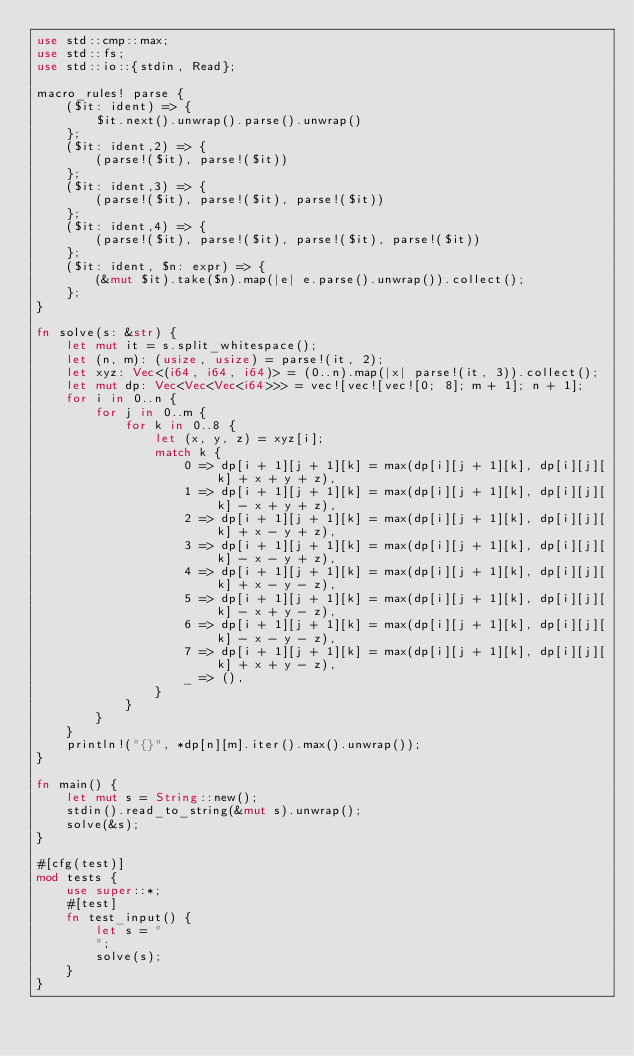Convert code to text. <code><loc_0><loc_0><loc_500><loc_500><_Rust_>use std::cmp::max;
use std::fs;
use std::io::{stdin, Read};

macro_rules! parse {
    ($it: ident) => {
        $it.next().unwrap().parse().unwrap()
    };
    ($it: ident,2) => {
        (parse!($it), parse!($it))
    };
    ($it: ident,3) => {
        (parse!($it), parse!($it), parse!($it))
    };
    ($it: ident,4) => {
        (parse!($it), parse!($it), parse!($it), parse!($it))
    };
    ($it: ident, $n: expr) => {
        (&mut $it).take($n).map(|e| e.parse().unwrap()).collect();
    };
}

fn solve(s: &str) {
    let mut it = s.split_whitespace();
    let (n, m): (usize, usize) = parse!(it, 2);
    let xyz: Vec<(i64, i64, i64)> = (0..n).map(|x| parse!(it, 3)).collect();
    let mut dp: Vec<Vec<Vec<i64>>> = vec![vec![vec![0; 8]; m + 1]; n + 1];
    for i in 0..n {
        for j in 0..m {
            for k in 0..8 {
                let (x, y, z) = xyz[i];
                match k {
                    0 => dp[i + 1][j + 1][k] = max(dp[i][j + 1][k], dp[i][j][k] + x + y + z),
                    1 => dp[i + 1][j + 1][k] = max(dp[i][j + 1][k], dp[i][j][k] - x + y + z),
                    2 => dp[i + 1][j + 1][k] = max(dp[i][j + 1][k], dp[i][j][k] + x - y + z),
                    3 => dp[i + 1][j + 1][k] = max(dp[i][j + 1][k], dp[i][j][k] - x - y + z),
                    4 => dp[i + 1][j + 1][k] = max(dp[i][j + 1][k], dp[i][j][k] + x - y - z),
                    5 => dp[i + 1][j + 1][k] = max(dp[i][j + 1][k], dp[i][j][k] - x + y - z),
                    6 => dp[i + 1][j + 1][k] = max(dp[i][j + 1][k], dp[i][j][k] - x - y - z),
                    7 => dp[i + 1][j + 1][k] = max(dp[i][j + 1][k], dp[i][j][k] + x + y - z),
                    _ => (),
                }
            }
        }
    }
    println!("{}", *dp[n][m].iter().max().unwrap());
}

fn main() {
    let mut s = String::new();
    stdin().read_to_string(&mut s).unwrap();
    solve(&s);
}

#[cfg(test)]
mod tests {
    use super::*;
    #[test]
    fn test_input() {
        let s = "
        ";
        solve(s);
    }
}
</code> 